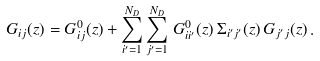<formula> <loc_0><loc_0><loc_500><loc_500>G _ { i j } ( z ) = G ^ { 0 } _ { i j } ( z ) + \sum _ { i ^ { \prime } = 1 } ^ { N _ { D } } \sum _ { j ^ { \prime } = 1 } ^ { N _ { D } } \, G ^ { 0 } _ { i i ^ { \prime } } ( z ) \, \Sigma _ { i ^ { \prime } j ^ { \prime } } ( z ) \, G _ { j ^ { \prime } j } ( z ) \, .</formula> 